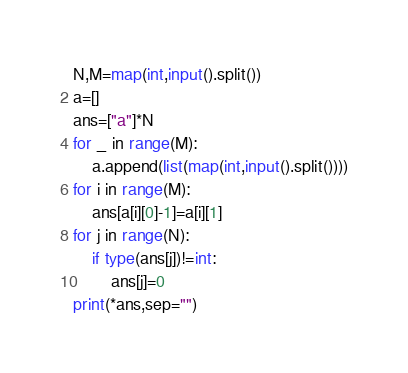<code> <loc_0><loc_0><loc_500><loc_500><_Python_>N,M=map(int,input().split())
a=[]
ans=["a"]*N
for _ in range(M):
    a.append(list(map(int,input().split())))
for i in range(M):
    ans[a[i][0]-1]=a[i][1]
for j in range(N):
    if type(ans[j])!=int:
        ans[j]=0
print(*ans,sep="")</code> 